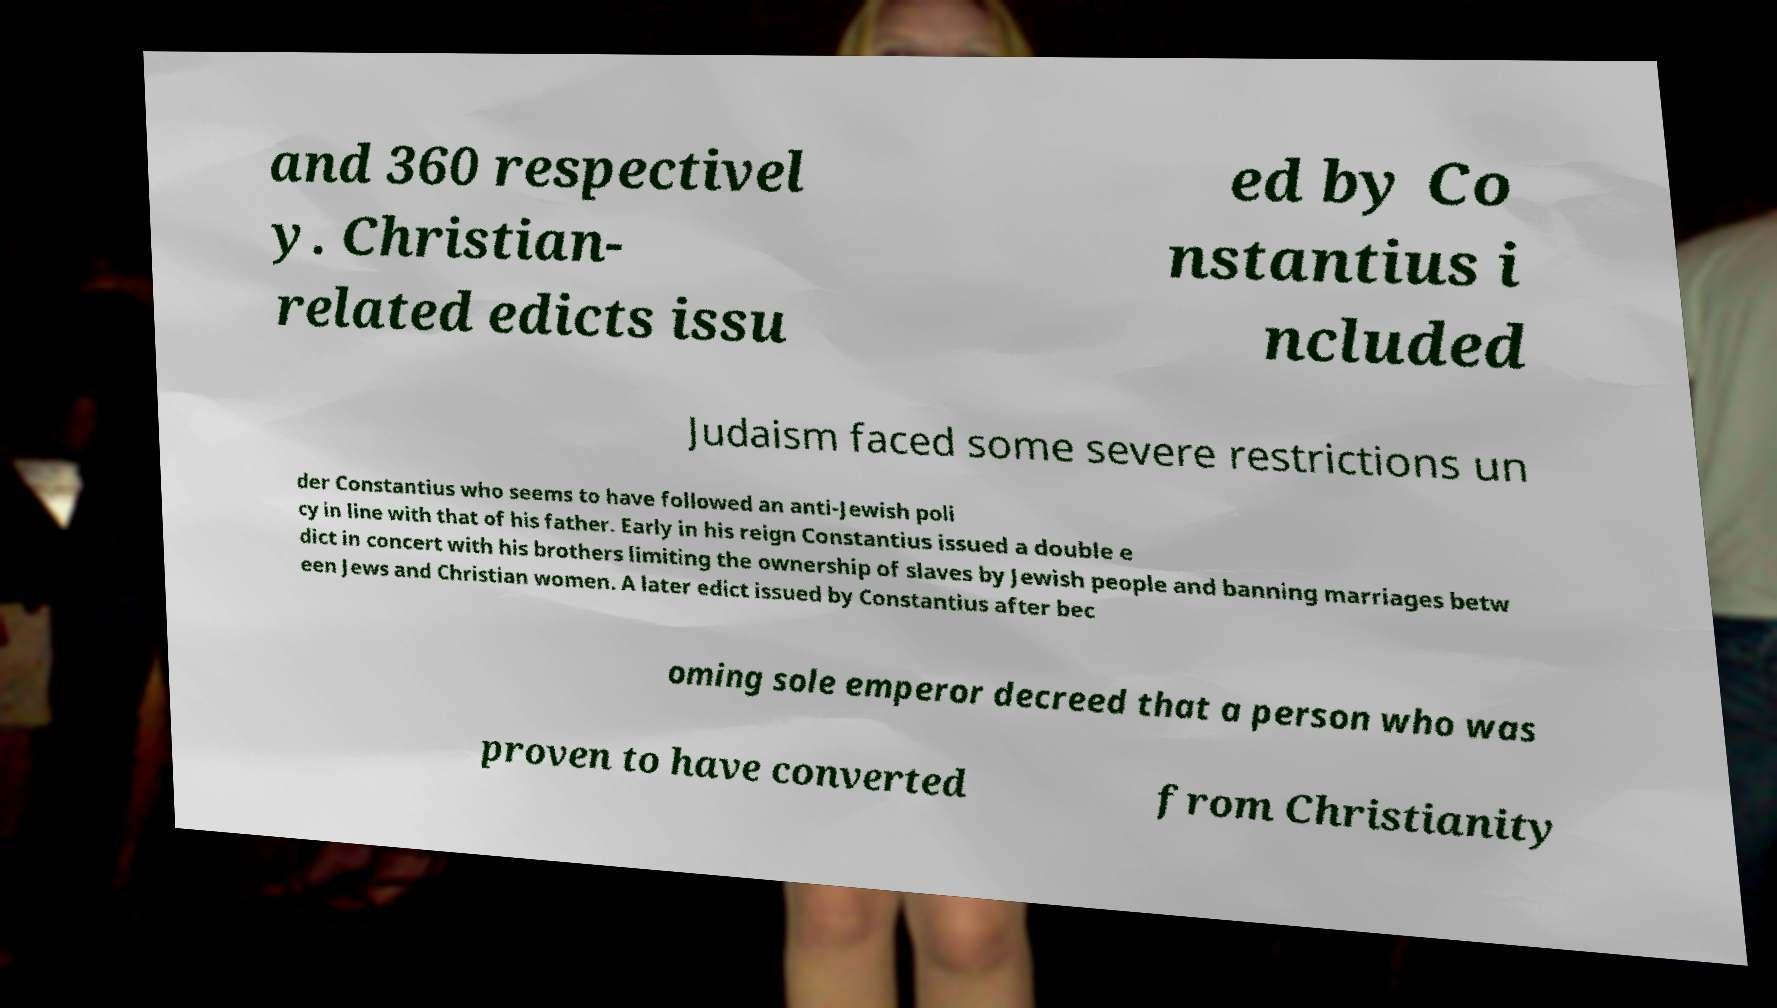Could you assist in decoding the text presented in this image and type it out clearly? and 360 respectivel y. Christian- related edicts issu ed by Co nstantius i ncluded Judaism faced some severe restrictions un der Constantius who seems to have followed an anti-Jewish poli cy in line with that of his father. Early in his reign Constantius issued a double e dict in concert with his brothers limiting the ownership of slaves by Jewish people and banning marriages betw een Jews and Christian women. A later edict issued by Constantius after bec oming sole emperor decreed that a person who was proven to have converted from Christianity 